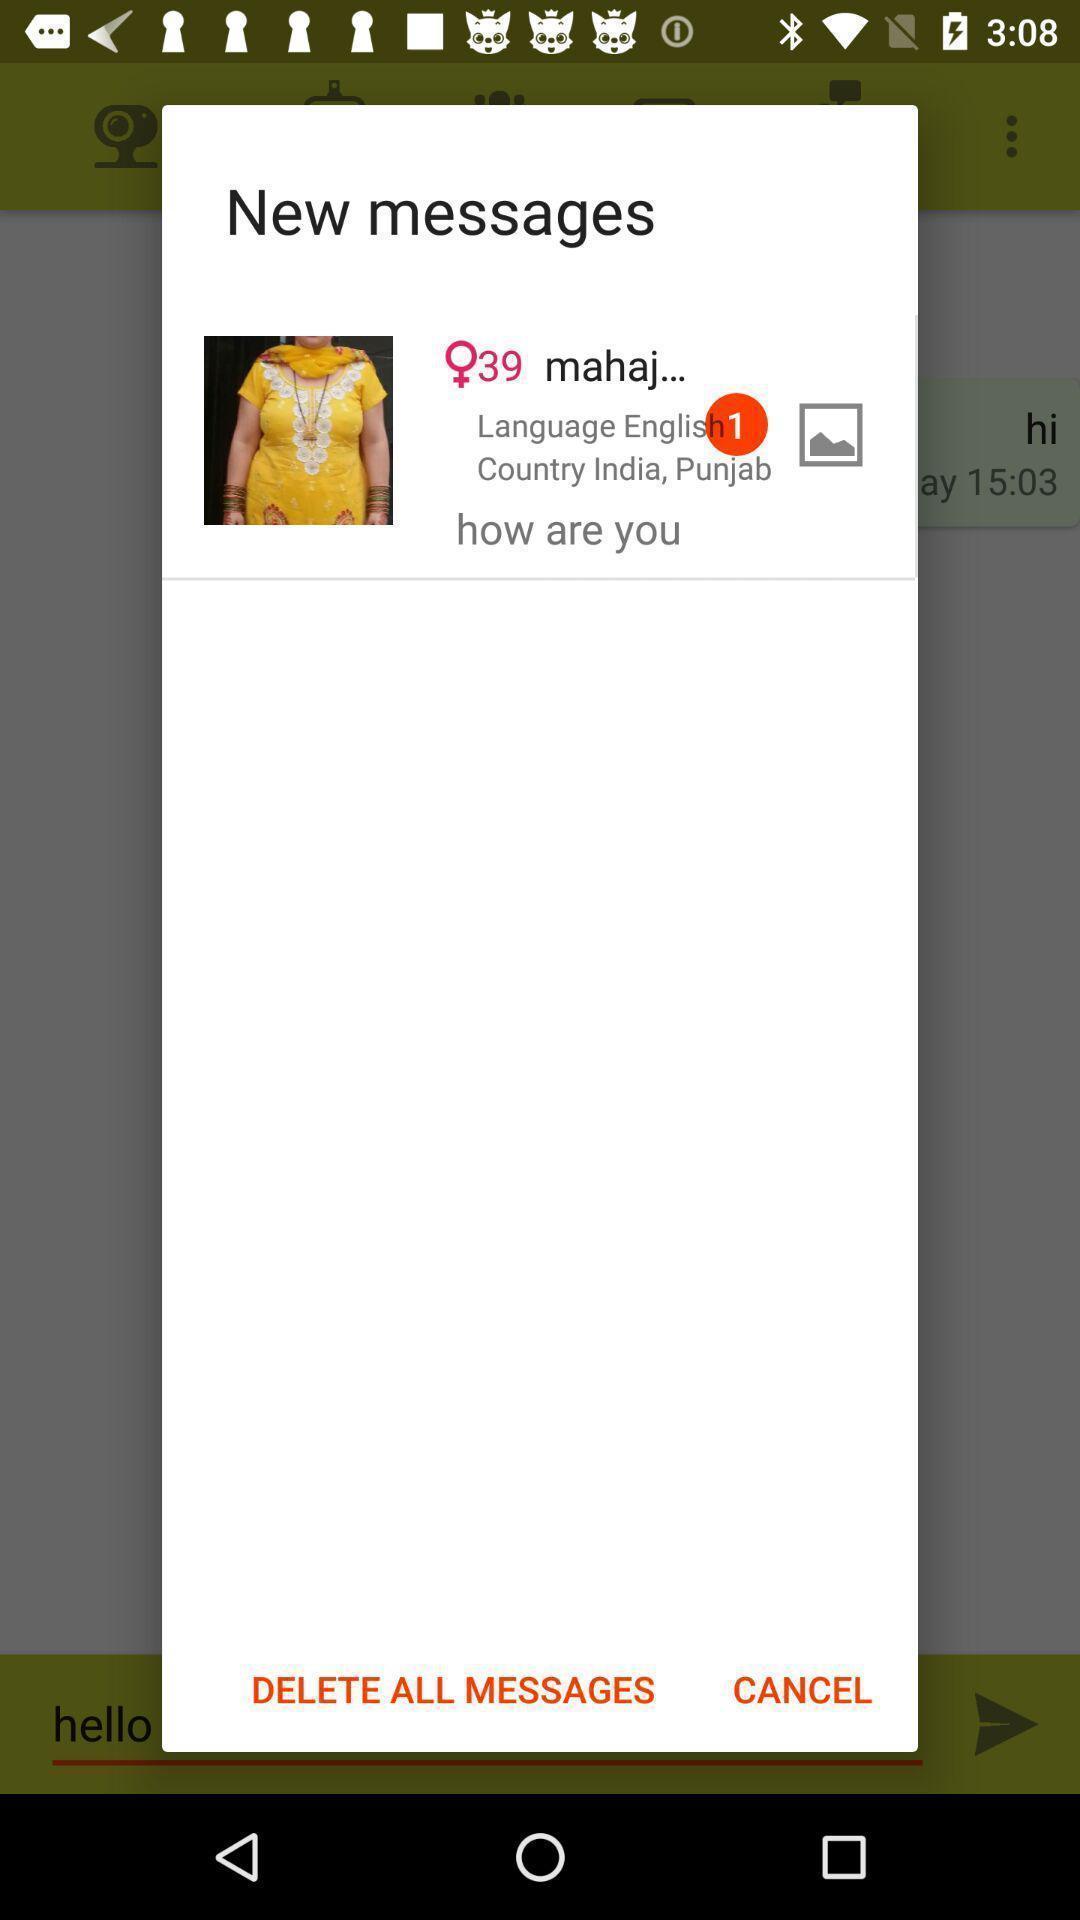Describe the visual elements of this screenshot. Screen shows new messages alert in the app. 